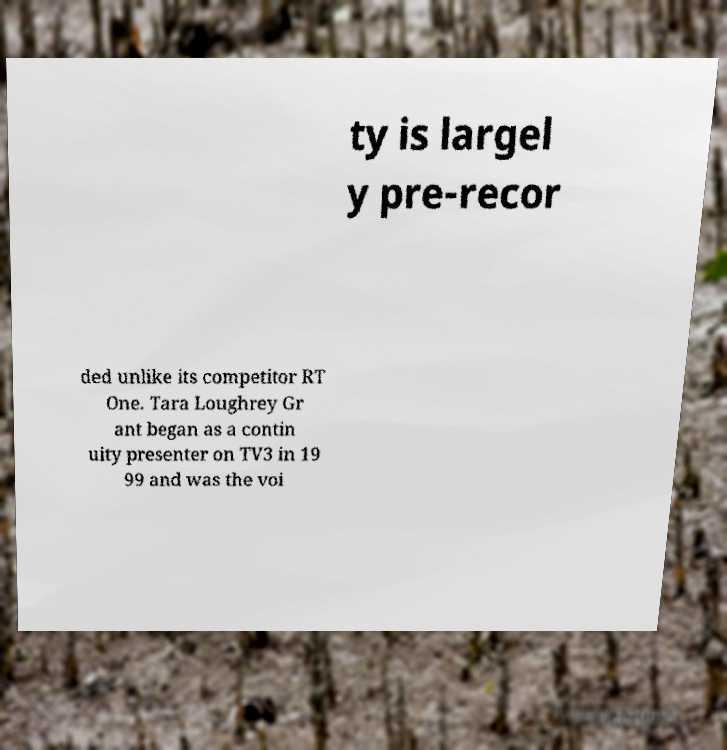Can you accurately transcribe the text from the provided image for me? ty is largel y pre-recor ded unlike its competitor RT One. Tara Loughrey Gr ant began as a contin uity presenter on TV3 in 19 99 and was the voi 